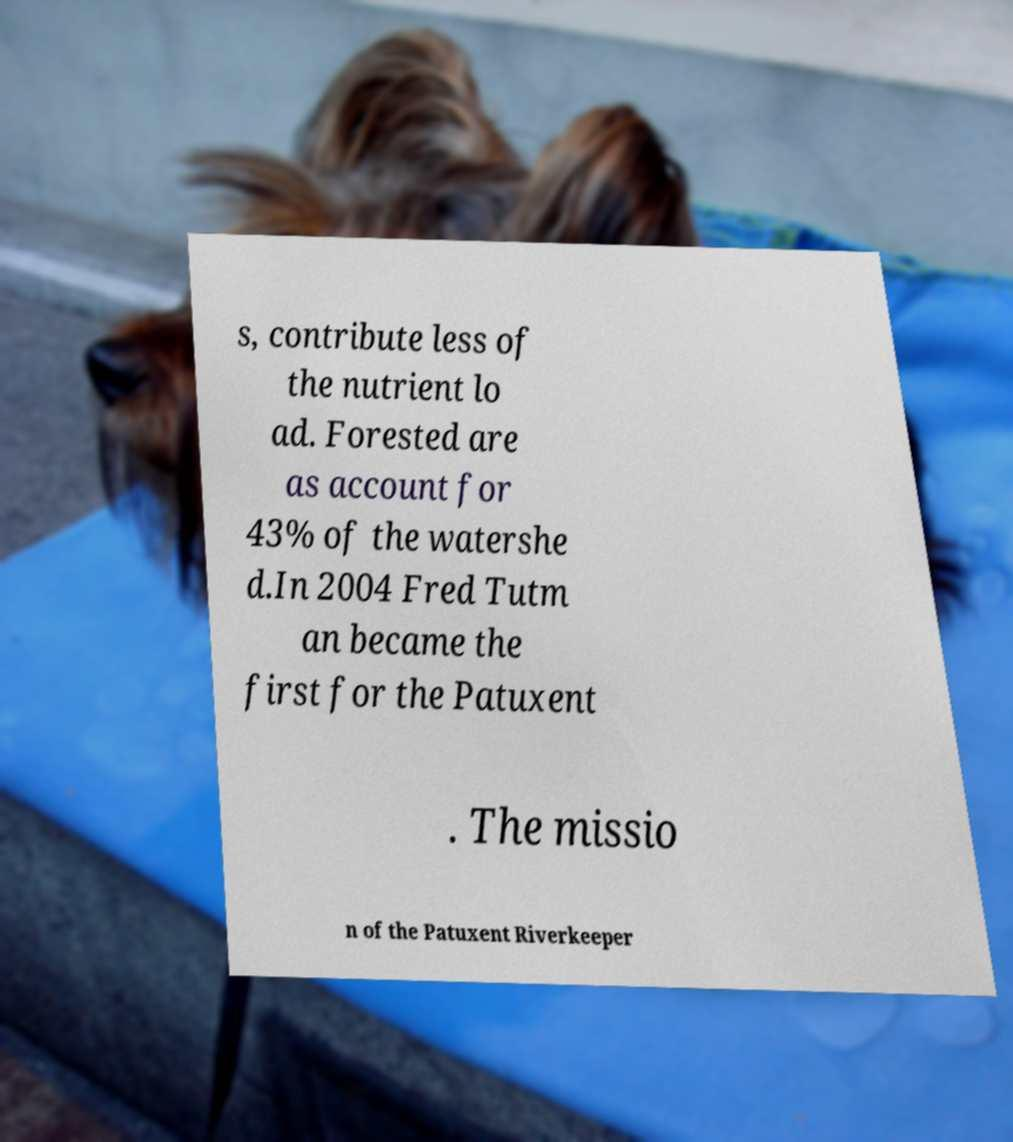I need the written content from this picture converted into text. Can you do that? s, contribute less of the nutrient lo ad. Forested are as account for 43% of the watershe d.In 2004 Fred Tutm an became the first for the Patuxent . The missio n of the Patuxent Riverkeeper 